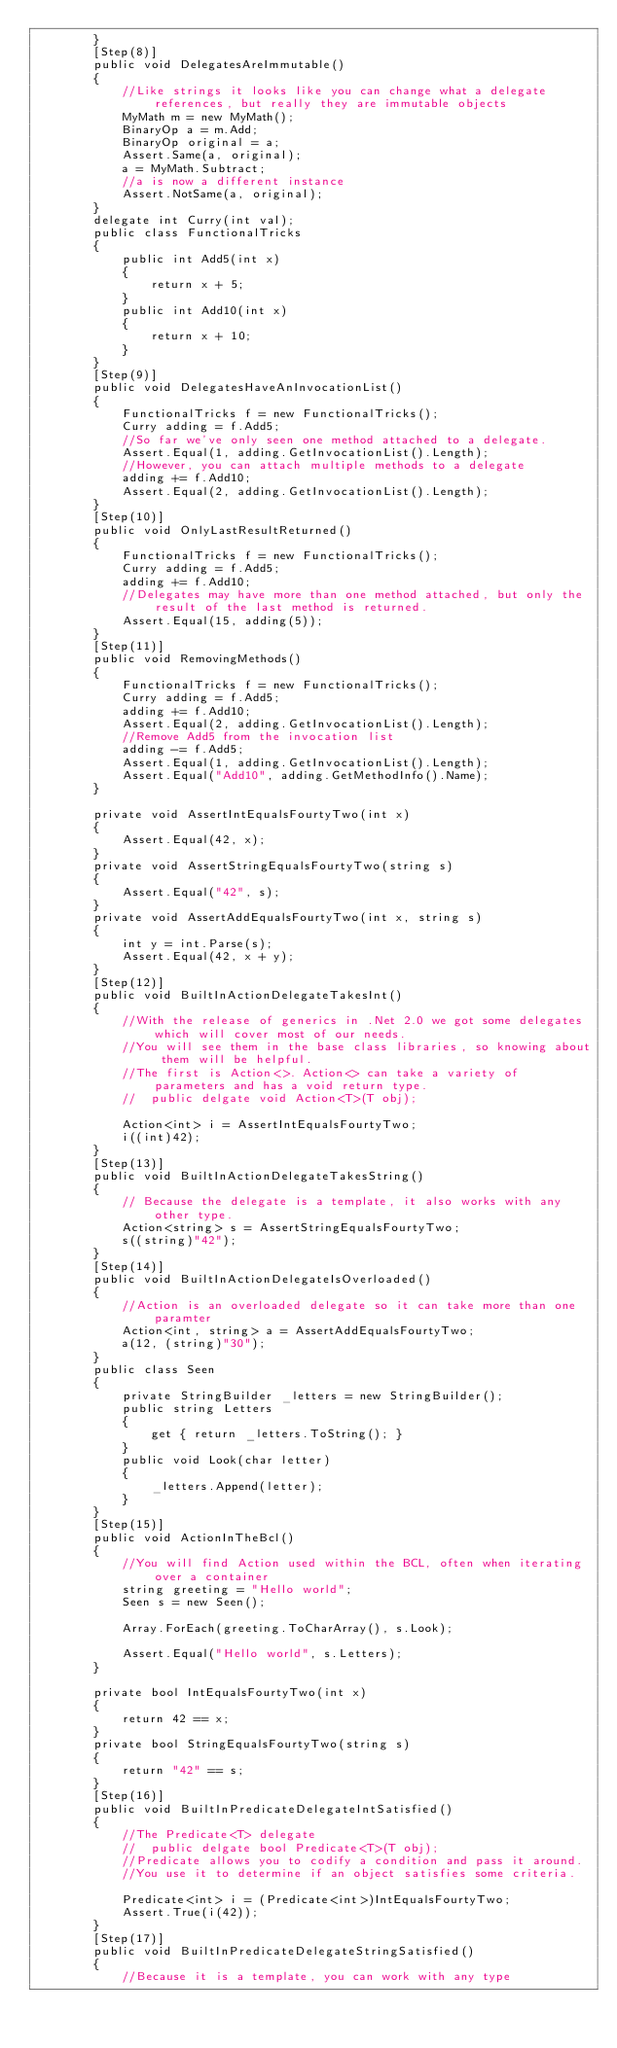Convert code to text. <code><loc_0><loc_0><loc_500><loc_500><_C#_>        }
        [Step(8)]
        public void DelegatesAreImmutable()
        {
            //Like strings it looks like you can change what a delegate references, but really they are immutable objects
            MyMath m = new MyMath();
            BinaryOp a = m.Add;
            BinaryOp original = a;
            Assert.Same(a, original);
            a = MyMath.Subtract;
            //a is now a different instance
            Assert.NotSame(a, original);
        }
        delegate int Curry(int val);
        public class FunctionalTricks
        {
            public int Add5(int x)
            {
                return x + 5;
            }
            public int Add10(int x)
            {
                return x + 10;
            }
        }
        [Step(9)]
        public void DelegatesHaveAnInvocationList()
        {
            FunctionalTricks f = new FunctionalTricks();
            Curry adding = f.Add5;
            //So far we've only seen one method attached to a delegate. 
            Assert.Equal(1, adding.GetInvocationList().Length);
            //However, you can attach multiple methods to a delegate 
            adding += f.Add10;
            Assert.Equal(2, adding.GetInvocationList().Length);
        }
        [Step(10)]
        public void OnlyLastResultReturned()
        {
            FunctionalTricks f = new FunctionalTricks();
            Curry adding = f.Add5;
            adding += f.Add10;
            //Delegates may have more than one method attached, but only the result of the last method is returned.
            Assert.Equal(15, adding(5));
        }
        [Step(11)]
        public void RemovingMethods()
        {
            FunctionalTricks f = new FunctionalTricks();
            Curry adding = f.Add5;
            adding += f.Add10;
            Assert.Equal(2, adding.GetInvocationList().Length);
            //Remove Add5 from the invocation list
            adding -= f.Add5;
            Assert.Equal(1, adding.GetInvocationList().Length);
            Assert.Equal("Add10", adding.GetMethodInfo().Name);
        }

        private void AssertIntEqualsFourtyTwo(int x)
        {
            Assert.Equal(42, x);
        }
        private void AssertStringEqualsFourtyTwo(string s)
        {
            Assert.Equal("42", s);
        }
        private void AssertAddEqualsFourtyTwo(int x, string s)
        {
            int y = int.Parse(s);
            Assert.Equal(42, x + y);
        }
        [Step(12)]
        public void BuiltInActionDelegateTakesInt()
        {
            //With the release of generics in .Net 2.0 we got some delegates which will cover most of our needs. 
            //You will see them in the base class libraries, so knowing about them will be helpful. 
            //The first is Action<>. Action<> can take a variety of parameters and has a void return type.
            //  public delgate void Action<T>(T obj);

            Action<int> i = AssertIntEqualsFourtyTwo;
            i((int)42);
        }
        [Step(13)]
        public void BuiltInActionDelegateTakesString()
        {
            // Because the delegate is a template, it also works with any other type. 
            Action<string> s = AssertStringEqualsFourtyTwo;
            s((string)"42");
        }
        [Step(14)]
        public void BuiltInActionDelegateIsOverloaded()
        {
            //Action is an overloaded delegate so it can take more than one paramter
            Action<int, string> a = AssertAddEqualsFourtyTwo;
            a(12, (string)"30");
        }
        public class Seen
        {
            private StringBuilder _letters = new StringBuilder();
            public string Letters
            {
                get { return _letters.ToString(); }
            }
            public void Look(char letter)
            {
                _letters.Append(letter);
            }
        }
        [Step(15)]
        public void ActionInTheBcl()
        {
            //You will find Action used within the BCL, often when iterating over a container
            string greeting = "Hello world";
            Seen s = new Seen();

            Array.ForEach(greeting.ToCharArray(), s.Look);

            Assert.Equal("Hello world", s.Letters);
        }

        private bool IntEqualsFourtyTwo(int x)
        {
            return 42 == x;
        }
        private bool StringEqualsFourtyTwo(string s)
        {
            return "42" == s;
        }
        [Step(16)]
        public void BuiltInPredicateDelegateIntSatisfied()
        {
            //The Predicate<T> delegate 
            //  public delgate bool Predicate<T>(T obj);
            //Predicate allows you to codify a condition and pass it around. 
            //You use it to determine if an object satisfies some criteria. 

            Predicate<int> i = (Predicate<int>)IntEqualsFourtyTwo;
            Assert.True(i(42));
        }
        [Step(17)]
        public void BuiltInPredicateDelegateStringSatisfied()
        {
            //Because it is a template, you can work with any type</code> 